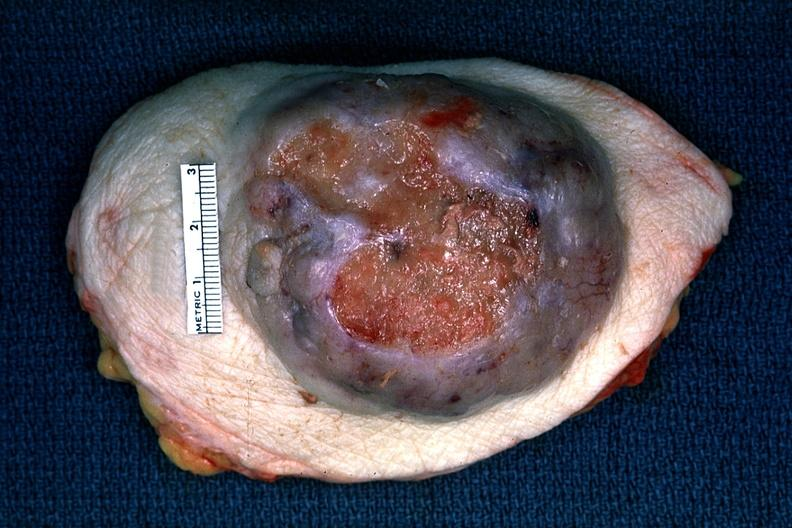does peritoneum show huge ulcerating carcinoma surgical specimen?
Answer the question using a single word or phrase. No 